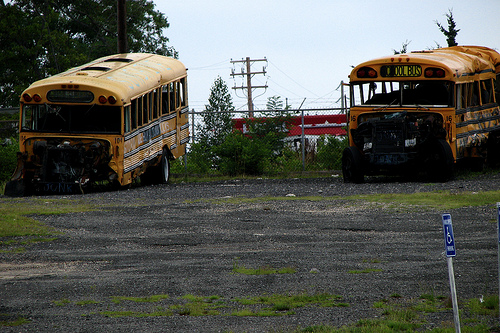Can you tell the type of area where these buses are parked? The buses are parked in a gravel lot which appears to be quite barren and unused, typically indicative of an industrial or outskirts area where such vehicles are commonly stored away from urban settings. Is there any signage visible that might indicate the location or purpose of this lot? No visible signage is evident from the image that would indicate the specific purpose or location of the lot, leaving its exact use somewhat ambiguous. 